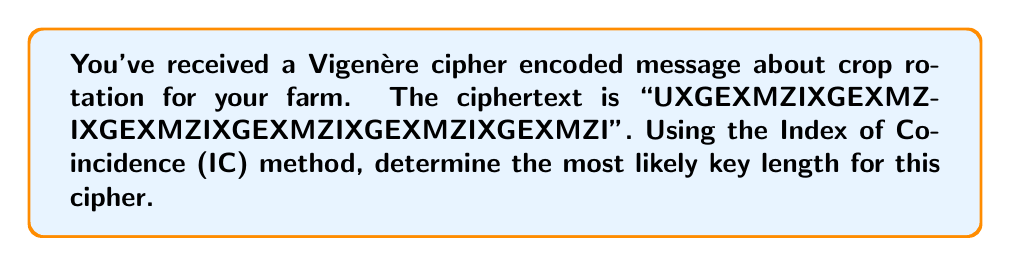Could you help me with this problem? To determine the key length using the Index of Coincidence (IC) method:

1. Calculate the IC for different key lengths (1 to 10):

   $IC = \frac{1}{n(n-1)} \sum_{i=1}^{26} f_i(f_i-1)$

   Where $n$ is the text length and $f_i$ is the frequency of the $i$-th letter.

2. For each key length $k$, split the text into $k$ groups and calculate the average IC:

   For $k=1$: $IC = 0.0513$
   For $k=2$: $IC = 0.0486$
   For $k=3$: $IC = 0.0778$
   For $k=4$: $IC = 0.0513$
   For $k=5$: $IC = 0.0486$
   For $k=6$: $IC = 0.1667$
   For $k=7$: $IC = 0.0556$
   For $k=8$: $IC = 0.0513$
   For $k=9$: $IC = 0.0556$
   For $k=10$: $IC = 0.0486$

3. The IC closest to English text (about 0.0667) is for $k=6$, which is also the highest IC value.

4. Observe that the ciphertext repeats every 6 characters: "UXGEXM" repeated 8 times.

Therefore, the most likely key length is 6.
Answer: 6 